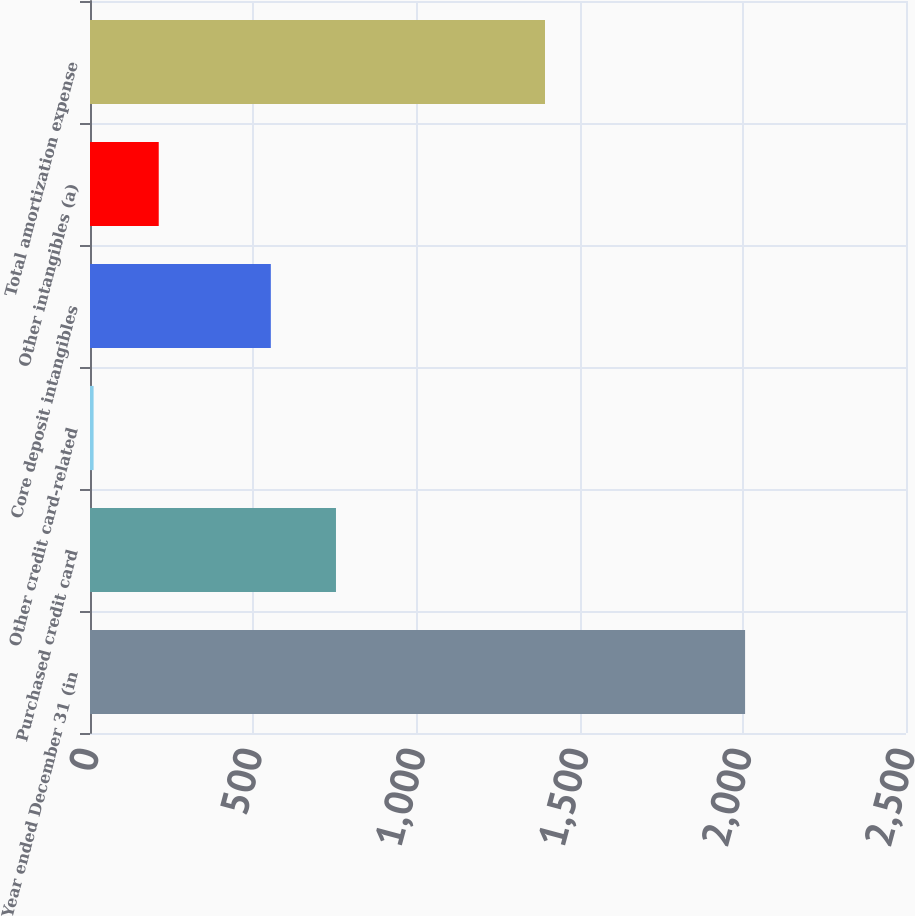Convert chart. <chart><loc_0><loc_0><loc_500><loc_500><bar_chart><fcel>Year ended December 31 (in<fcel>Purchased credit card<fcel>Other credit card-related<fcel>Core deposit intangibles<fcel>Other intangibles (a)<fcel>Total amortization expense<nl><fcel>2007<fcel>753.6<fcel>11<fcel>554<fcel>210.6<fcel>1394<nl></chart> 